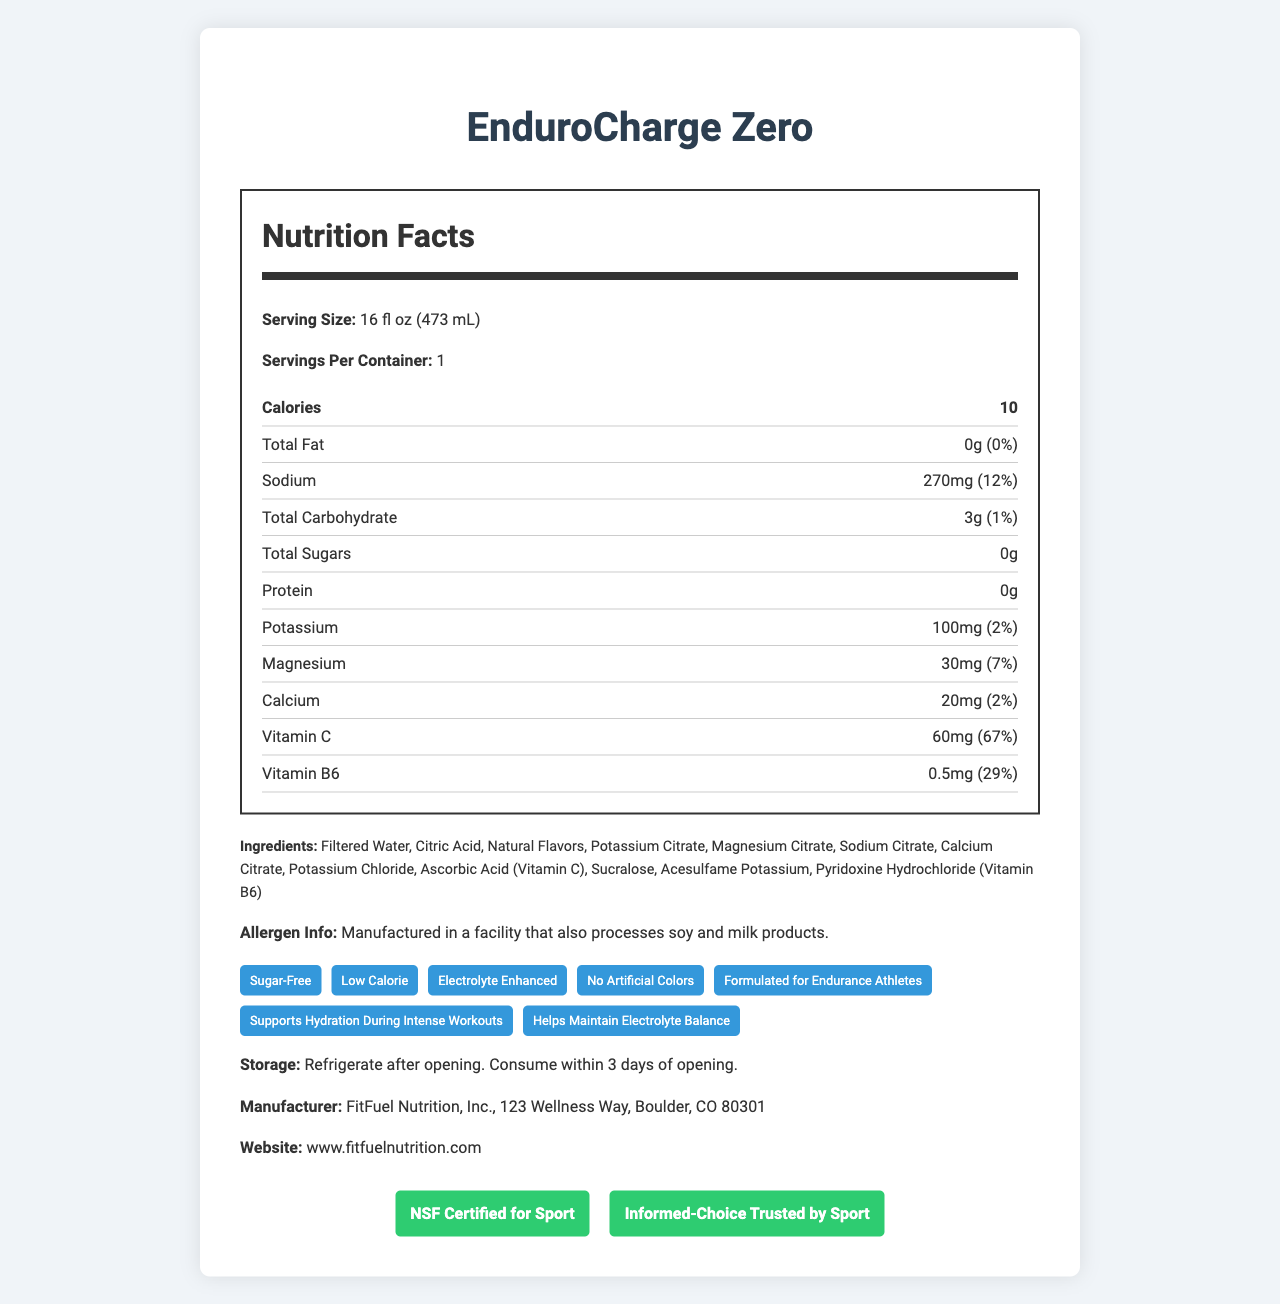what is the calorie count per serving? The document states that the calories per serving are 10.
Answer: 10 how much sodium does one serving of this drink contain? The sodium amount per serving is listed as 270 mg.
Answer: 270 mg what percentage of the Daily Value (DV) for potassium does this beverage provide? The document lists the Daily Value percentage for potassium as 2%.
Answer: 2% what is the serving size for this sports drink? The serving size is mentioned as 16 fl oz (473 mL).
Answer: 16 fl oz (473 mL) what is the name of the manufacturer? The document lists the manufacturer's name as FitFuel Nutrition, Inc.
Answer: FitFuel Nutrition, Inc. which of the following nutrients is NOT present in this drink? A. Protein B. Calcium C. Vitamin D The document lists protein, calcium, and vitamin C, but no mention of vitamin D.
Answer: C. Vitamin D is there any sugar in the EnduroCharge Zero sports drink? The document clearly states that the total sugars amount is 0g.
Answer: No does this drink contain any allergens? The allergen information indicates that it is manufactured in a facility that also processes soy and milk products.
Answer: Yes what is the main purpose of this document? The document details the nutritional facts, ingredients, health claims, and certifications of the drink, aiming to inform potential consumers about its benefits.
Answer: To provide nutritional information and highlight key features of the EnduroCharge Zero sports drink what is the exact address of the manufacturer? The document provides the address as "123 Wellness Way, Boulder, CO 80301" but does not specify any further.
Answer: Not enough information what are the main electrolytes present in this sports drink? The nutrients list includes sodium, potassium, magnesium, and calcium, which are all important electrolytes for maintaining electrolyte balance.
Answer: Sodium, Potassium, Magnesium, Calcium what additional health claims does the marketing make about this drink? The document includes these specific health claims in the marketing section.
Answer: Formulated for Endurance Athletes, Supports Hydration During Intense Workouts, Helps Maintain Electrolyte Balance 